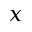<formula> <loc_0><loc_0><loc_500><loc_500>x</formula> 